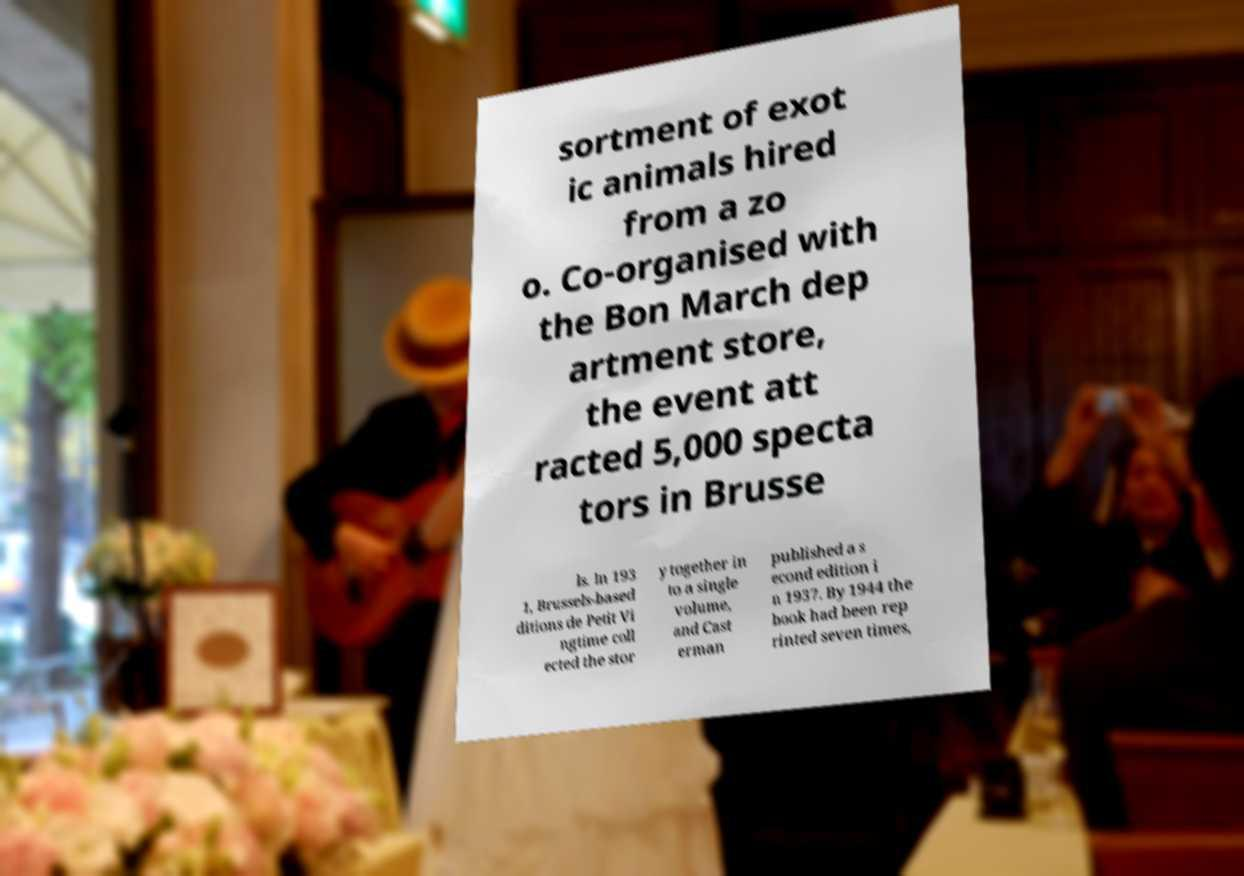Please read and relay the text visible in this image. What does it say? sortment of exot ic animals hired from a zo o. Co-organised with the Bon March dep artment store, the event att racted 5,000 specta tors in Brusse ls. In 193 1, Brussels-based ditions de Petit Vi ngtime coll ected the stor y together in to a single volume, and Cast erman published a s econd edition i n 1937. By 1944 the book had been rep rinted seven times, 